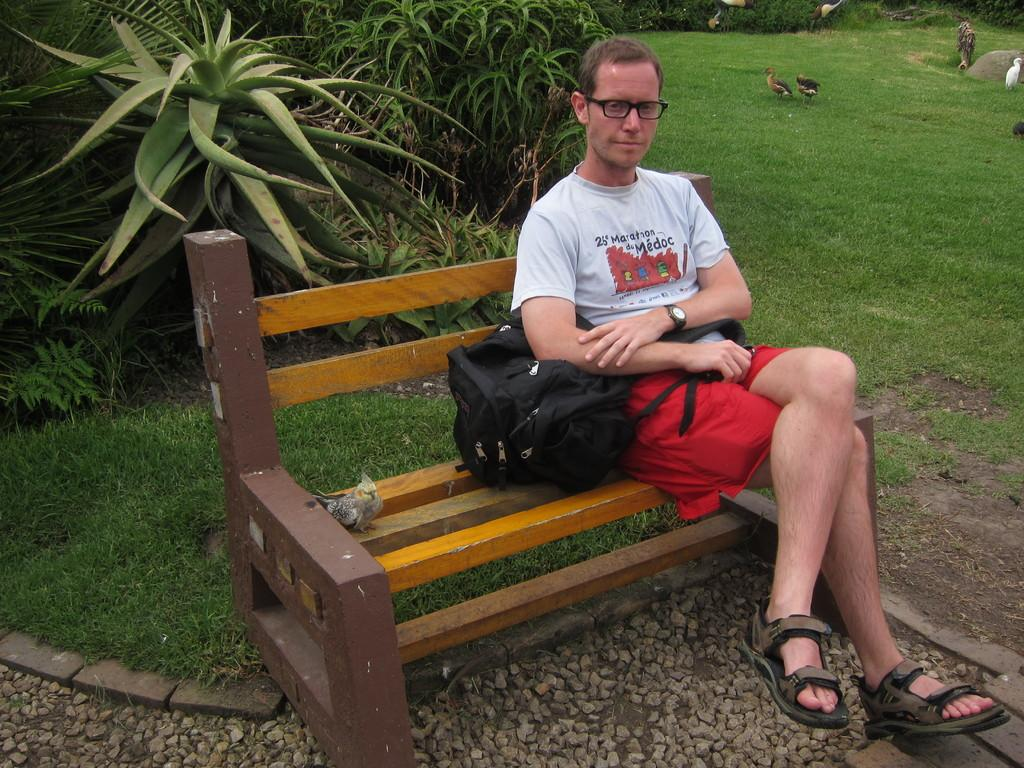What is the man doing in the image? There is a man sitting on a park bench in the image. What is the man holding? The man is holding a backpack. What can be seen walking on the grass in the image? There are birds walking on the grass. What type of vegetation is visible behind the man? There are garden plants behind the man. What type of knife is the man using to cut the tree in the image? There is no knife or tree present in the image. The man is sitting on a park bench and holding a backpack, while birds are walking on the grass and garden plants are visible behind him. 